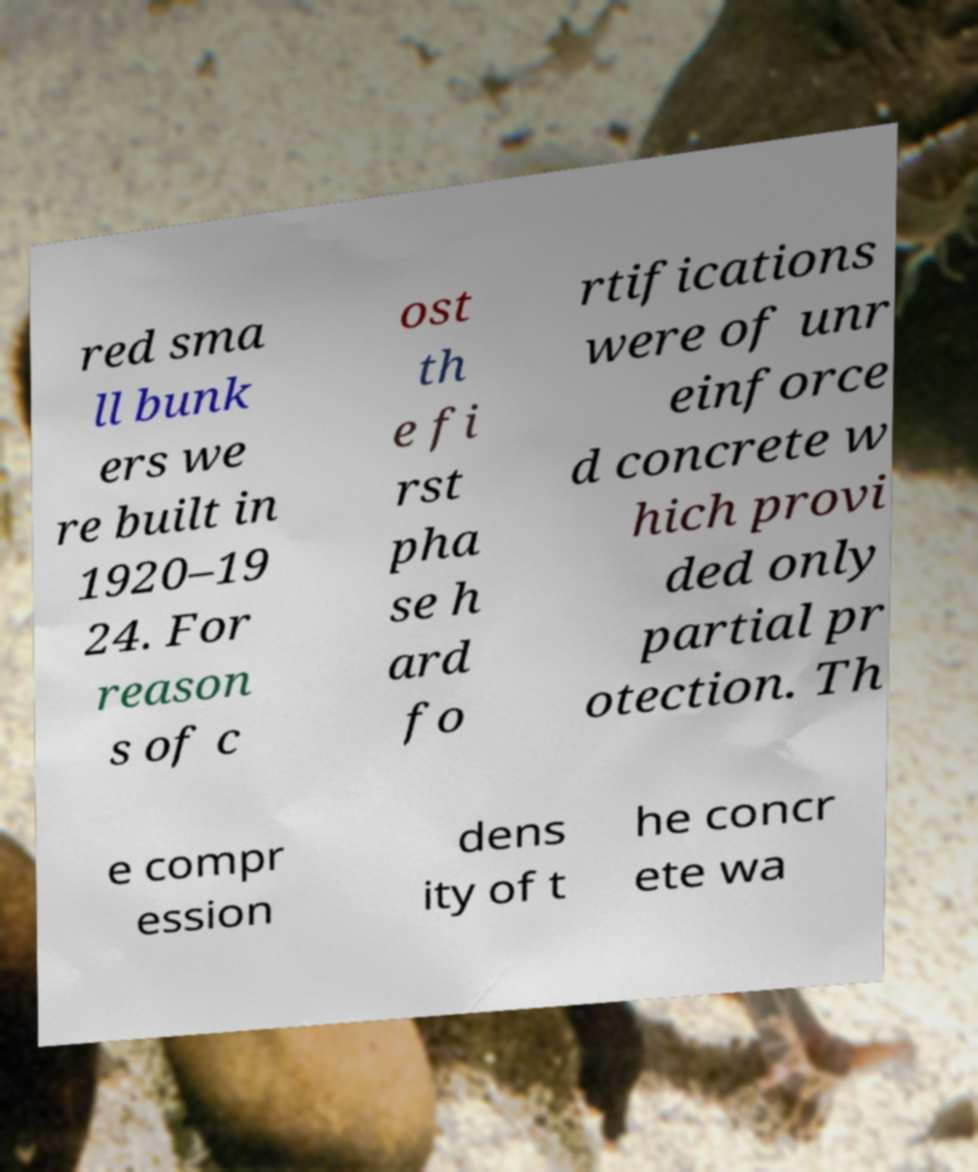For documentation purposes, I need the text within this image transcribed. Could you provide that? red sma ll bunk ers we re built in 1920–19 24. For reason s of c ost th e fi rst pha se h ard fo rtifications were of unr einforce d concrete w hich provi ded only partial pr otection. Th e compr ession dens ity of t he concr ete wa 